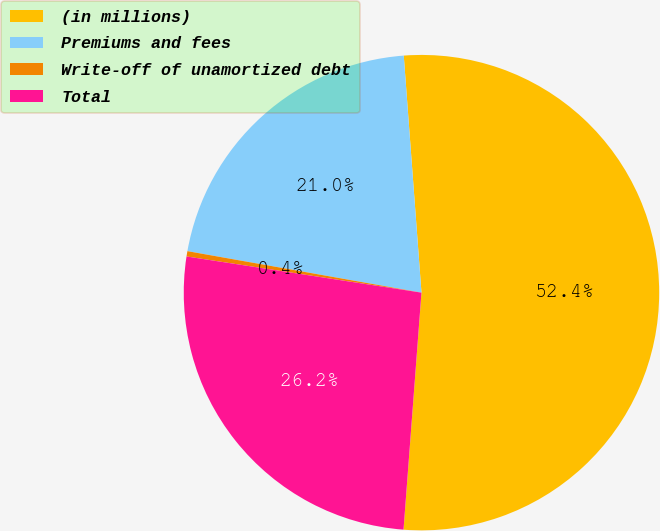Convert chart. <chart><loc_0><loc_0><loc_500><loc_500><pie_chart><fcel>(in millions)<fcel>Premiums and fees<fcel>Write-off of unamortized debt<fcel>Total<nl><fcel>52.39%<fcel>21.02%<fcel>0.36%<fcel>26.23%<nl></chart> 